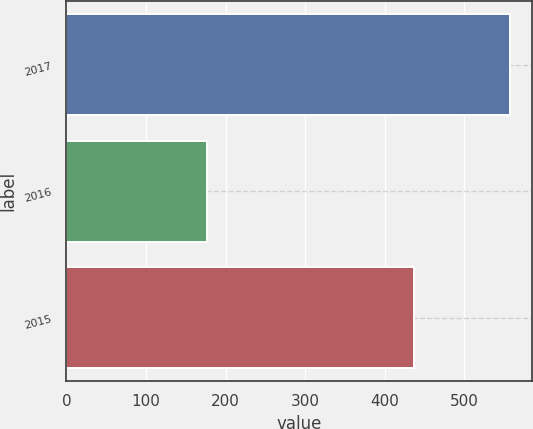Convert chart. <chart><loc_0><loc_0><loc_500><loc_500><bar_chart><fcel>2017<fcel>2016<fcel>2015<nl><fcel>557<fcel>177<fcel>437<nl></chart> 